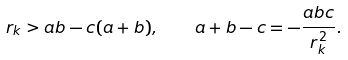<formula> <loc_0><loc_0><loc_500><loc_500>r _ { k } > a b - c ( a + b ) , \quad a + b - c = - \frac { a b c } { r _ { k } ^ { 2 } } .</formula> 